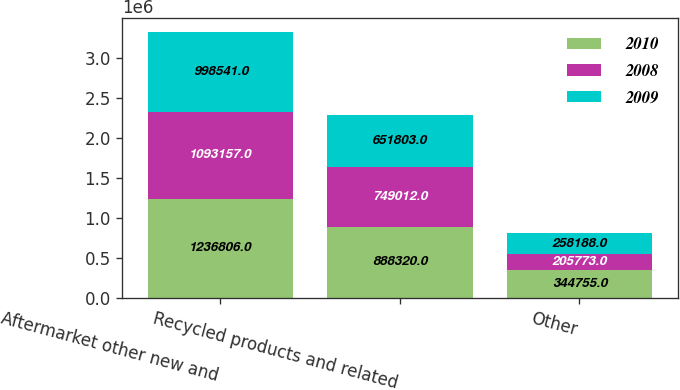Convert chart. <chart><loc_0><loc_0><loc_500><loc_500><stacked_bar_chart><ecel><fcel>Aftermarket other new and<fcel>Recycled products and related<fcel>Other<nl><fcel>2010<fcel>1.23681e+06<fcel>888320<fcel>344755<nl><fcel>2008<fcel>1.09316e+06<fcel>749012<fcel>205773<nl><fcel>2009<fcel>998541<fcel>651803<fcel>258188<nl></chart> 